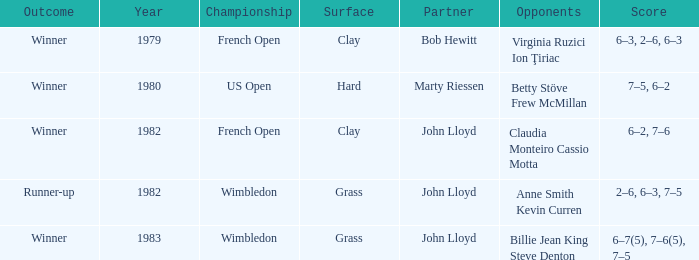What was the surface for events held in 1983? Grass. 